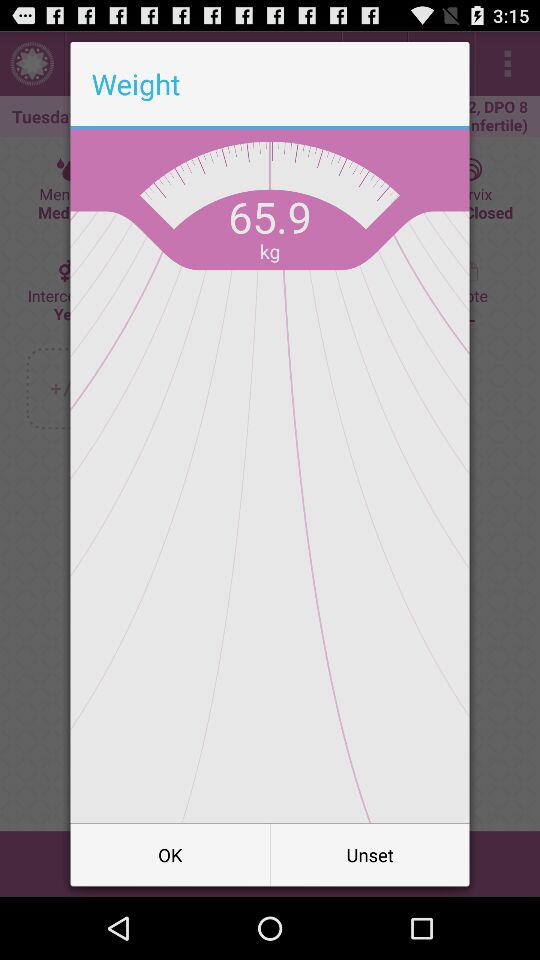What is the weight of the person on the scale?
Answer the question using a single word or phrase. 65.9 kg 